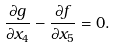<formula> <loc_0><loc_0><loc_500><loc_500>\frac { \partial g } { \partial x _ { 4 } } - \frac { \partial f } { \partial x _ { 5 } } = 0 .</formula> 